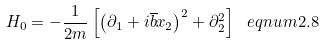<formula> <loc_0><loc_0><loc_500><loc_500>H _ { 0 } = - \frac { 1 } { 2 m } \left [ \left ( \partial _ { 1 } + i \overline { b } x _ { 2 } \right ) ^ { 2 } + \partial _ { 2 } ^ { 2 } \right ] \ e q n u m { 2 . 8 }</formula> 